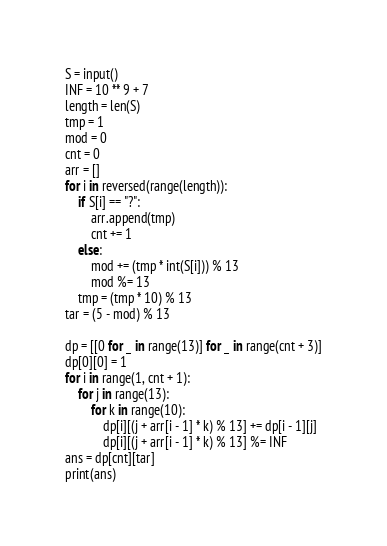<code> <loc_0><loc_0><loc_500><loc_500><_Python_>S = input()
INF = 10 ** 9 + 7
length = len(S)
tmp = 1
mod = 0
cnt = 0
arr = []
for i in reversed(range(length)):
    if S[i] == "?":
        arr.append(tmp)
        cnt += 1
    else:
        mod += (tmp * int(S[i])) % 13
        mod %= 13
    tmp = (tmp * 10) % 13
tar = (5 - mod) % 13

dp = [[0 for _ in range(13)] for _ in range(cnt + 3)]
dp[0][0] = 1
for i in range(1, cnt + 1):
    for j in range(13):
        for k in range(10):
            dp[i][(j + arr[i - 1] * k) % 13] += dp[i - 1][j]
            dp[i][(j + arr[i - 1] * k) % 13] %= INF
ans = dp[cnt][tar]
print(ans)</code> 